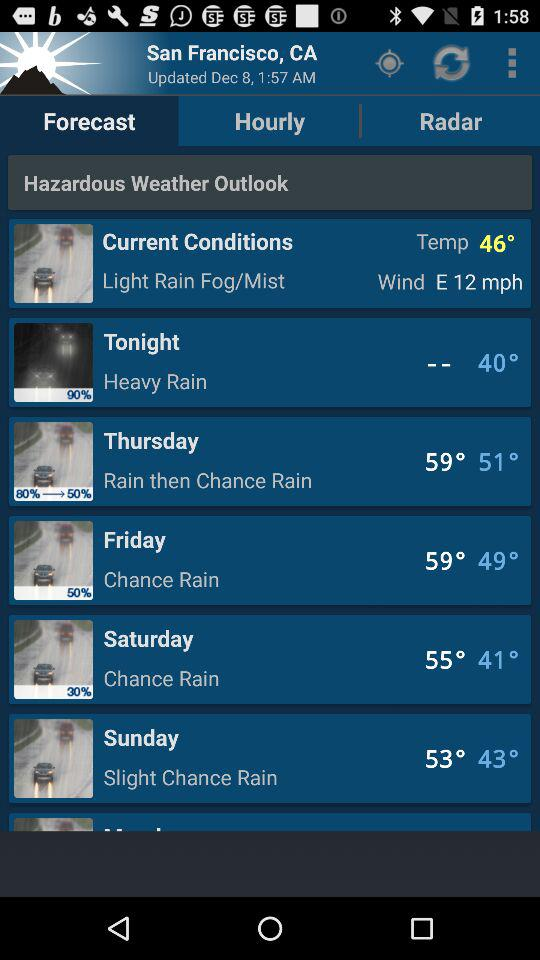What is the location? The location is San Francisco, CA. 